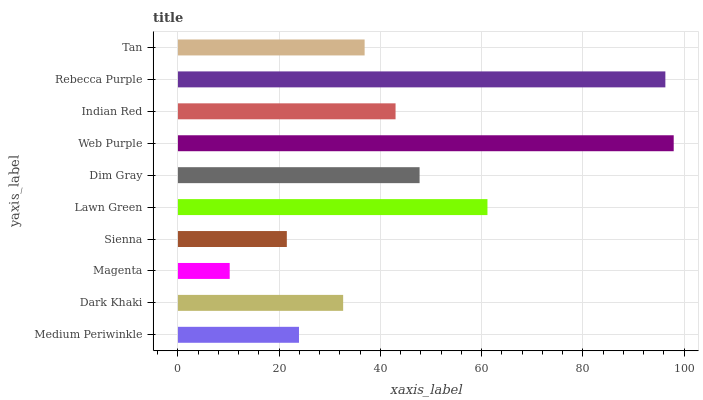Is Magenta the minimum?
Answer yes or no. Yes. Is Web Purple the maximum?
Answer yes or no. Yes. Is Dark Khaki the minimum?
Answer yes or no. No. Is Dark Khaki the maximum?
Answer yes or no. No. Is Dark Khaki greater than Medium Periwinkle?
Answer yes or no. Yes. Is Medium Periwinkle less than Dark Khaki?
Answer yes or no. Yes. Is Medium Periwinkle greater than Dark Khaki?
Answer yes or no. No. Is Dark Khaki less than Medium Periwinkle?
Answer yes or no. No. Is Indian Red the high median?
Answer yes or no. Yes. Is Tan the low median?
Answer yes or no. Yes. Is Lawn Green the high median?
Answer yes or no. No. Is Dim Gray the low median?
Answer yes or no. No. 